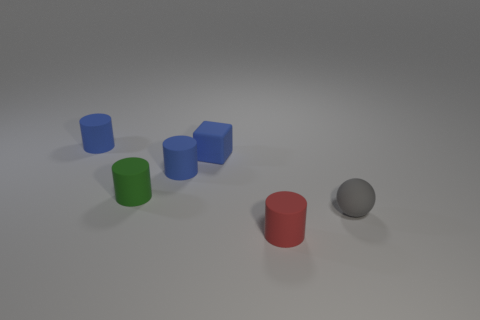What number of tiny blue matte cubes are on the right side of the rubber object that is to the right of the red rubber object?
Ensure brevity in your answer.  0. What shape is the object that is both in front of the tiny green matte cylinder and behind the red rubber object?
Make the answer very short. Sphere. What number of things have the same color as the rubber ball?
Make the answer very short. 0. There is a small object that is right of the rubber cylinder that is in front of the tiny ball; are there any small gray matte spheres behind it?
Your answer should be compact. No. What is the size of the cylinder that is both on the right side of the small green thing and behind the gray thing?
Your response must be concise. Small. How many blue cylinders are made of the same material as the tiny red cylinder?
Keep it short and to the point. 2. How many cylinders are either large objects or red rubber things?
Your answer should be very brief. 1. How big is the object on the right side of the small thing in front of the thing to the right of the red thing?
Make the answer very short. Small. There is a small cylinder that is right of the green thing and to the left of the small blue rubber cube; what color is it?
Ensure brevity in your answer.  Blue. There is a red rubber thing; is its size the same as the blue matte cylinder that is on the left side of the small green thing?
Offer a terse response. Yes. 